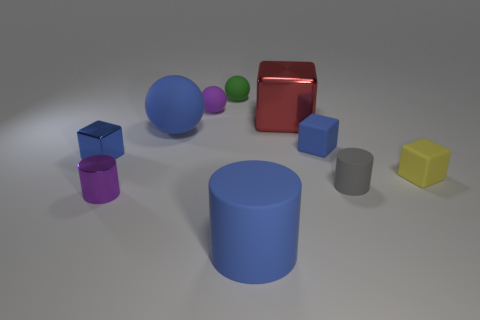Subtract all cylinders. How many objects are left? 7 Subtract all blue cubes. How many cubes are left? 2 Subtract 1 purple cylinders. How many objects are left? 9 Subtract 3 cubes. How many cubes are left? 1 Subtract all purple blocks. Subtract all brown spheres. How many blocks are left? 4 Subtract all cyan cylinders. How many green cubes are left? 0 Subtract all tiny metallic things. Subtract all red balls. How many objects are left? 8 Add 6 blue metal blocks. How many blue metal blocks are left? 7 Add 8 large gray shiny cubes. How many large gray shiny cubes exist? 8 Subtract all blue balls. How many balls are left? 2 